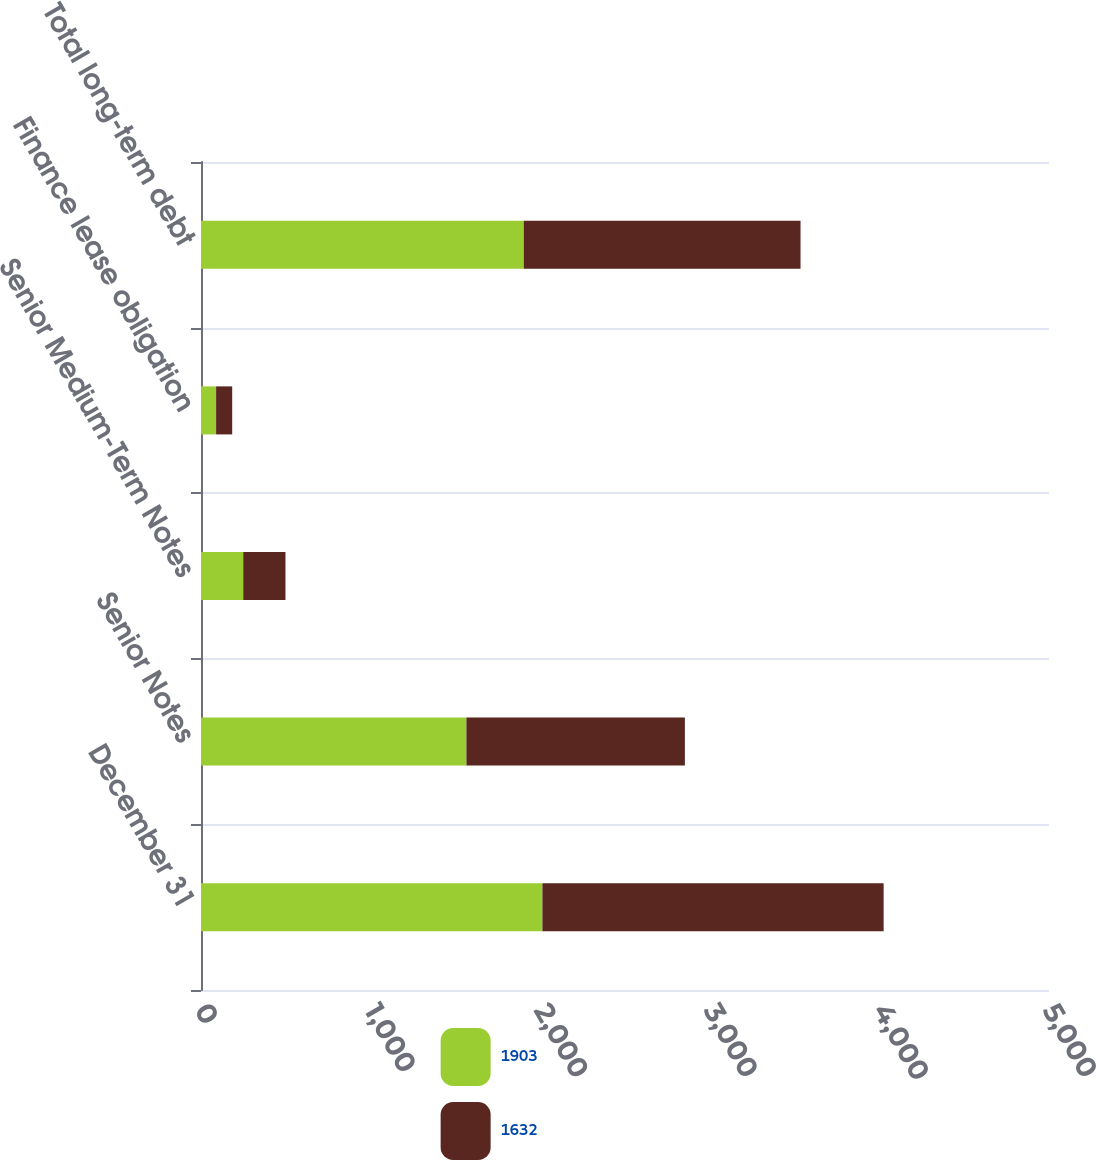Convert chart to OTSL. <chart><loc_0><loc_0><loc_500><loc_500><stacked_bar_chart><ecel><fcel>December 31<fcel>Senior Notes<fcel>Senior Medium-Term Notes<fcel>Finance lease obligation<fcel>Total long-term debt<nl><fcel>1903<fcel>2013<fcel>1565<fcel>249<fcel>89<fcel>1903<nl><fcel>1632<fcel>2012<fcel>1288<fcel>249<fcel>95<fcel>1632<nl></chart> 